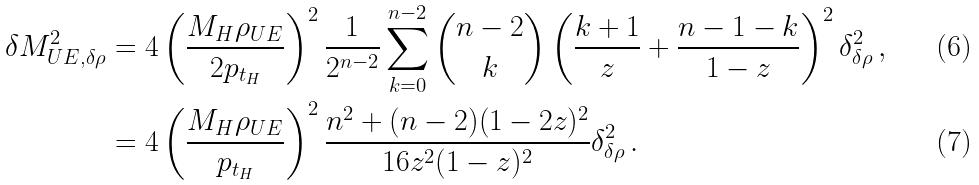<formula> <loc_0><loc_0><loc_500><loc_500>\delta M _ { U E , \delta \rho } ^ { 2 } & = 4 \left ( \frac { M _ { H } \rho _ { U E } } { 2 p _ { t _ { H } } } \right ) ^ { 2 } \frac { 1 } { 2 ^ { n - 2 } } \sum _ { k = 0 } ^ { n - 2 } \binom { n - 2 } { k } \left ( \frac { k + 1 } { z } + \frac { n - 1 - k } { 1 - z } \right ) ^ { 2 } \delta _ { \delta \rho } ^ { 2 } \, , \\ & = 4 \left ( \frac { M _ { H } \rho _ { U E } } { p _ { t _ { H } } } \right ) ^ { 2 } \frac { n ^ { 2 } + ( n - 2 ) ( 1 - 2 z ) ^ { 2 } } { 1 6 z ^ { 2 } ( 1 - z ) ^ { 2 } } \delta _ { \delta \rho } ^ { 2 } \, .</formula> 